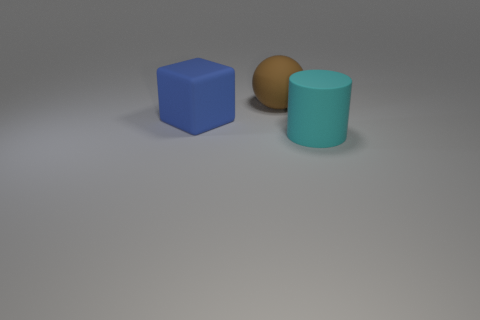How many spheres are tiny gray things or big matte things?
Offer a terse response. 1. What number of big rubber blocks are there?
Provide a succinct answer. 1. What number of objects are big blue rubber blocks or small red shiny things?
Give a very brief answer. 1. There is a thing on the left side of the large brown matte object that is behind the blue object; what shape is it?
Your answer should be compact. Cube. How many objects are either matte things that are behind the blue matte object or rubber things that are behind the cube?
Offer a very short reply. 1. Are there the same number of large cyan matte things to the right of the cyan cylinder and objects behind the blue rubber cube?
Give a very brief answer. No. There is a large matte object behind the blue cube; what color is it?
Your answer should be very brief. Brown. There is a large rubber block; is its color the same as the matte object behind the big blue thing?
Offer a very short reply. No. Are there fewer cubes than large things?
Make the answer very short. Yes. What number of green cylinders are the same size as the brown ball?
Make the answer very short. 0. 